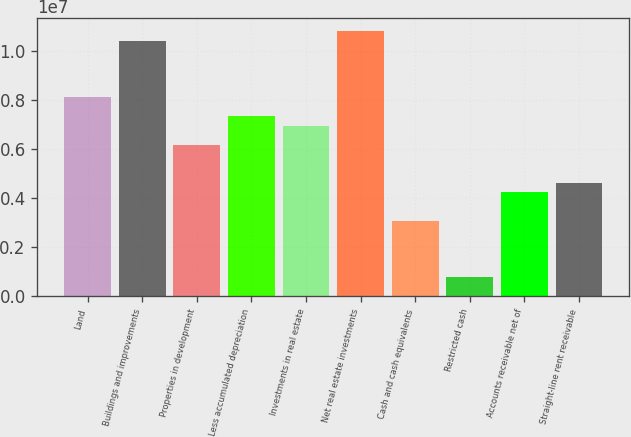<chart> <loc_0><loc_0><loc_500><loc_500><bar_chart><fcel>Land<fcel>Buildings and improvements<fcel>Properties in development<fcel>Less accumulated depreciation<fcel>Investments in real estate<fcel>Net real estate investments<fcel>Cash and cash equivalents<fcel>Restricted cash<fcel>Accounts receivable net of<fcel>Straight-line rent receivable<nl><fcel>8.09127e+06<fcel>1.04028e+07<fcel>6.16499e+06<fcel>7.32076e+06<fcel>6.9355e+06<fcel>1.07881e+07<fcel>3.08295e+06<fcel>771415<fcel>4.23871e+06<fcel>4.62397e+06<nl></chart> 